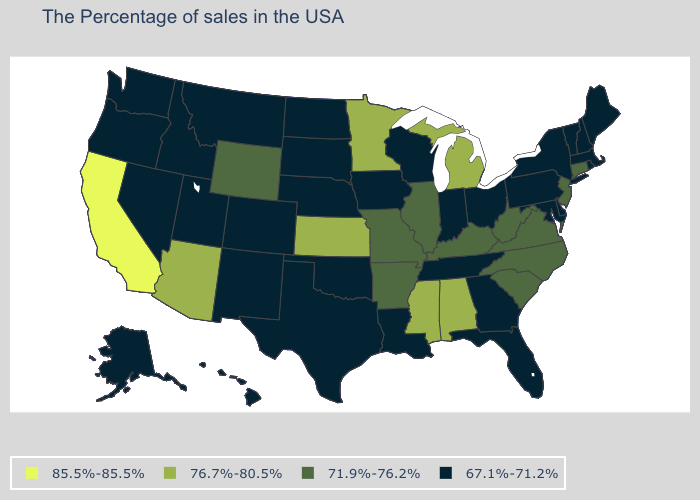How many symbols are there in the legend?
Quick response, please. 4. Among the states that border Georgia , which have the lowest value?
Answer briefly. Florida, Tennessee. Which states have the highest value in the USA?
Concise answer only. California. What is the lowest value in states that border Idaho?
Give a very brief answer. 67.1%-71.2%. What is the value of Utah?
Short answer required. 67.1%-71.2%. What is the value of Arizona?
Give a very brief answer. 76.7%-80.5%. Name the states that have a value in the range 71.9%-76.2%?
Give a very brief answer. Connecticut, New Jersey, Virginia, North Carolina, South Carolina, West Virginia, Kentucky, Illinois, Missouri, Arkansas, Wyoming. Is the legend a continuous bar?
Short answer required. No. Name the states that have a value in the range 85.5%-85.5%?
Write a very short answer. California. What is the value of New Jersey?
Concise answer only. 71.9%-76.2%. Name the states that have a value in the range 67.1%-71.2%?
Concise answer only. Maine, Massachusetts, Rhode Island, New Hampshire, Vermont, New York, Delaware, Maryland, Pennsylvania, Ohio, Florida, Georgia, Indiana, Tennessee, Wisconsin, Louisiana, Iowa, Nebraska, Oklahoma, Texas, South Dakota, North Dakota, Colorado, New Mexico, Utah, Montana, Idaho, Nevada, Washington, Oregon, Alaska, Hawaii. How many symbols are there in the legend?
Answer briefly. 4. Name the states that have a value in the range 71.9%-76.2%?
Write a very short answer. Connecticut, New Jersey, Virginia, North Carolina, South Carolina, West Virginia, Kentucky, Illinois, Missouri, Arkansas, Wyoming. Which states hav the highest value in the MidWest?
Be succinct. Michigan, Minnesota, Kansas. Which states have the highest value in the USA?
Be succinct. California. 